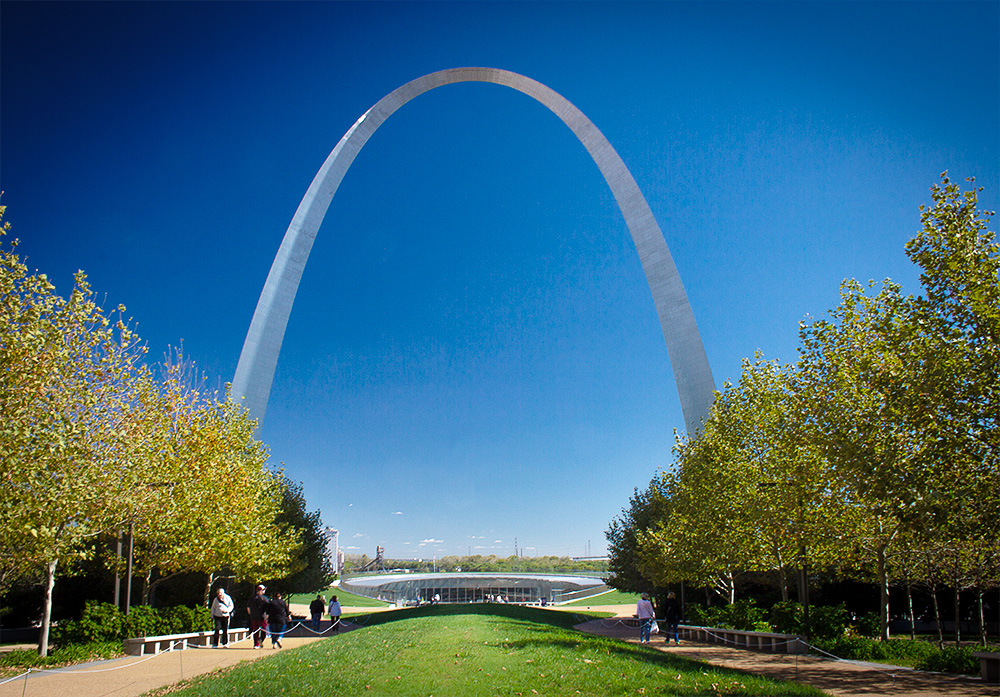Can you describe the main features of this image for me? The image captures the majestic Gateway Arch, a renowned landmark located in St. Louis, Missouri. This monument, standing tall at 630 feet, holds the record for being the tallest arch in the world. Its gleaming surface, made of stainless steel, reflects the clear blue sky above. The arch is perfectly centered in the image, its grandeur accentuated by the distance from which the photo is taken. The foreground is a lively scene with trees and people, adding a touch of life to the architectural marvel. The perspective is particularly striking, taken from the ground and looking up, it emphasizes the impressive height of the arch. The image is a beautiful blend of man-made wonder and natural beauty. 